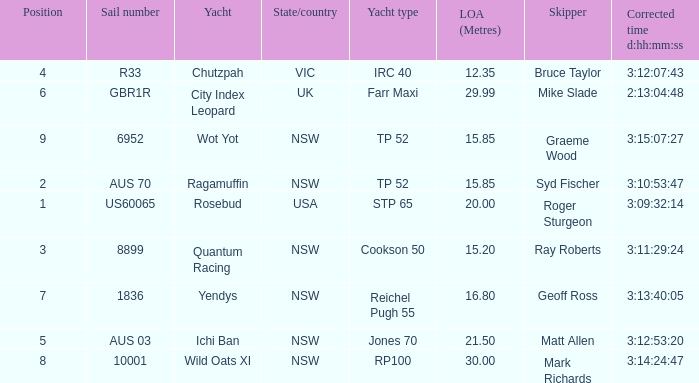Could you parse the entire table? {'header': ['Position', 'Sail number', 'Yacht', 'State/country', 'Yacht type', 'LOA (Metres)', 'Skipper', 'Corrected time d:hh:mm:ss'], 'rows': [['4', 'R33', 'Chutzpah', 'VIC', 'IRC 40', '12.35', 'Bruce Taylor', '3:12:07:43'], ['6', 'GBR1R', 'City Index Leopard', 'UK', 'Farr Maxi', '29.99', 'Mike Slade', '2:13:04:48'], ['9', '6952', 'Wot Yot', 'NSW', 'TP 52', '15.85', 'Graeme Wood', '3:15:07:27'], ['2', 'AUS 70', 'Ragamuffin', 'NSW', 'TP 52', '15.85', 'Syd Fischer', '3:10:53:47'], ['1', 'US60065', 'Rosebud', 'USA', 'STP 65', '20.00', 'Roger Sturgeon', '3:09:32:14'], ['3', '8899', 'Quantum Racing', 'NSW', 'Cookson 50', '15.20', 'Ray Roberts', '3:11:29:24'], ['7', '1836', 'Yendys', 'NSW', 'Reichel Pugh 55', '16.80', 'Geoff Ross', '3:13:40:05'], ['5', 'AUS 03', 'Ichi Ban', 'NSW', 'Jones 70', '21.50', 'Matt Allen', '3:12:53:20'], ['8', '10001', 'Wild Oats XI', 'NSW', 'RP100', '30.00', 'Mark Richards', '3:14:24:47']]} What are all of the states or countries with a corrected time 3:13:40:05? NSW. 